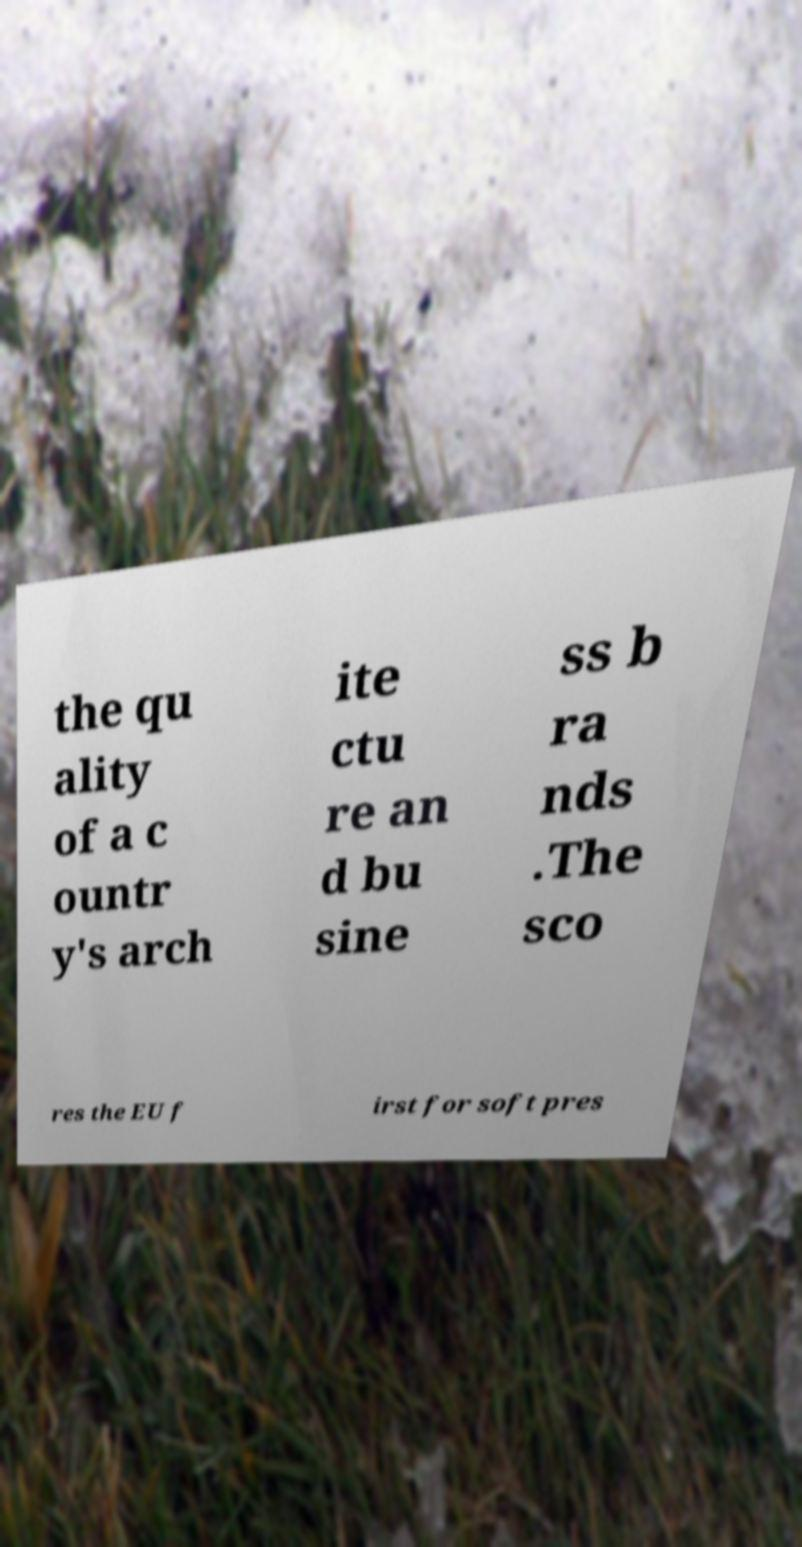Could you assist in decoding the text presented in this image and type it out clearly? the qu ality of a c ountr y's arch ite ctu re an d bu sine ss b ra nds .The sco res the EU f irst for soft pres 